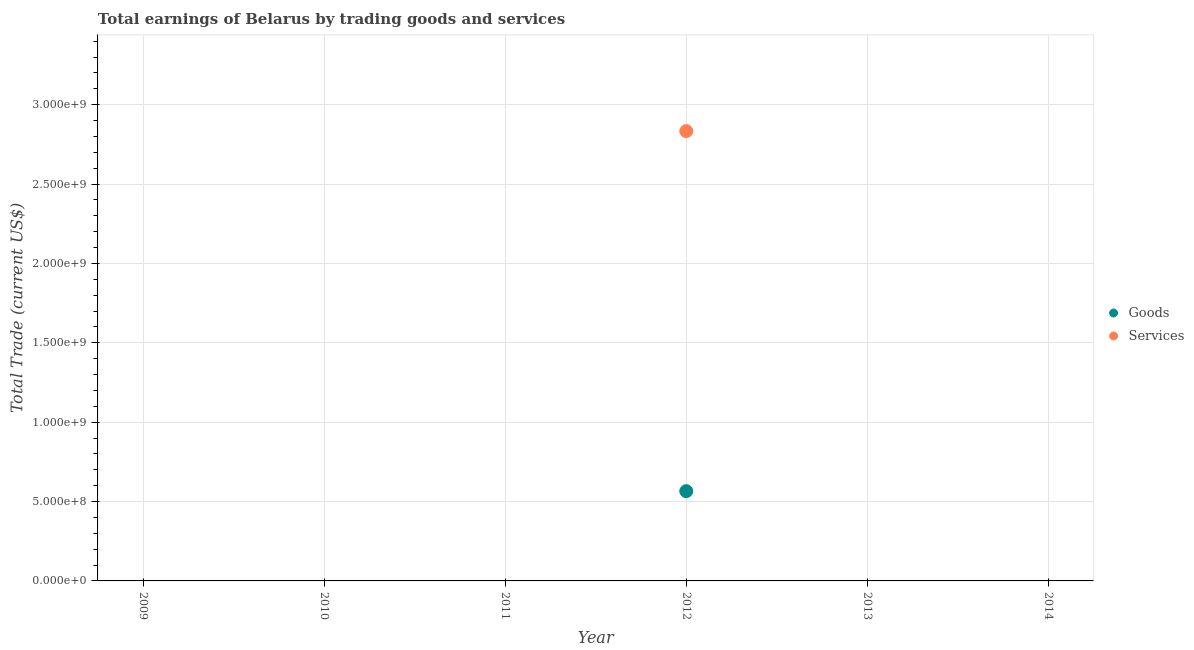How many different coloured dotlines are there?
Provide a succinct answer. 2. What is the amount earned by trading services in 2010?
Give a very brief answer. 0. Across all years, what is the maximum amount earned by trading services?
Keep it short and to the point. 2.83e+09. What is the total amount earned by trading goods in the graph?
Keep it short and to the point. 5.65e+08. What is the average amount earned by trading goods per year?
Your answer should be very brief. 9.42e+07. In the year 2012, what is the difference between the amount earned by trading goods and amount earned by trading services?
Your answer should be compact. -2.27e+09. In how many years, is the amount earned by trading goods greater than 100000000 US$?
Provide a short and direct response. 1. What is the difference between the highest and the lowest amount earned by trading goods?
Ensure brevity in your answer.  5.65e+08. In how many years, is the amount earned by trading services greater than the average amount earned by trading services taken over all years?
Offer a very short reply. 1. How many dotlines are there?
Your response must be concise. 2. Are the values on the major ticks of Y-axis written in scientific E-notation?
Keep it short and to the point. Yes. Does the graph contain grids?
Provide a succinct answer. Yes. How many legend labels are there?
Give a very brief answer. 2. How are the legend labels stacked?
Give a very brief answer. Vertical. What is the title of the graph?
Ensure brevity in your answer.  Total earnings of Belarus by trading goods and services. What is the label or title of the Y-axis?
Provide a succinct answer. Total Trade (current US$). What is the Total Trade (current US$) in Goods in 2009?
Make the answer very short. 0. What is the Total Trade (current US$) in Goods in 2010?
Your response must be concise. 0. What is the Total Trade (current US$) of Services in 2010?
Keep it short and to the point. 0. What is the Total Trade (current US$) of Services in 2011?
Provide a succinct answer. 0. What is the Total Trade (current US$) in Goods in 2012?
Ensure brevity in your answer.  5.65e+08. What is the Total Trade (current US$) in Services in 2012?
Make the answer very short. 2.83e+09. What is the Total Trade (current US$) in Goods in 2013?
Offer a terse response. 0. What is the Total Trade (current US$) in Services in 2013?
Your response must be concise. 0. What is the Total Trade (current US$) of Goods in 2014?
Your answer should be very brief. 0. Across all years, what is the maximum Total Trade (current US$) in Goods?
Your answer should be compact. 5.65e+08. Across all years, what is the maximum Total Trade (current US$) of Services?
Ensure brevity in your answer.  2.83e+09. Across all years, what is the minimum Total Trade (current US$) in Services?
Ensure brevity in your answer.  0. What is the total Total Trade (current US$) in Goods in the graph?
Your answer should be very brief. 5.65e+08. What is the total Total Trade (current US$) of Services in the graph?
Offer a very short reply. 2.83e+09. What is the average Total Trade (current US$) of Goods per year?
Keep it short and to the point. 9.42e+07. What is the average Total Trade (current US$) in Services per year?
Offer a very short reply. 4.72e+08. In the year 2012, what is the difference between the Total Trade (current US$) in Goods and Total Trade (current US$) in Services?
Keep it short and to the point. -2.27e+09. What is the difference between the highest and the lowest Total Trade (current US$) in Goods?
Provide a short and direct response. 5.65e+08. What is the difference between the highest and the lowest Total Trade (current US$) in Services?
Your answer should be very brief. 2.83e+09. 